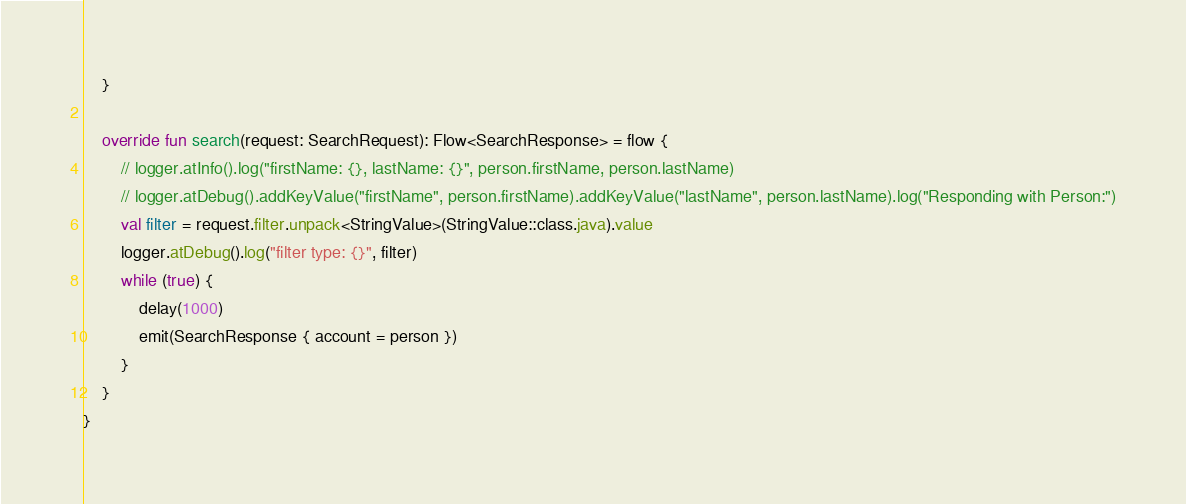<code> <loc_0><loc_0><loc_500><loc_500><_Kotlin_>    }

    override fun search(request: SearchRequest): Flow<SearchResponse> = flow {
        // logger.atInfo().log("firstName: {}, lastName: {}", person.firstName, person.lastName)
        // logger.atDebug().addKeyValue("firstName", person.firstName).addKeyValue("lastName", person.lastName).log("Responding with Person:")
        val filter = request.filter.unpack<StringValue>(StringValue::class.java).value
        logger.atDebug().log("filter type: {}", filter)
        while (true) {
            delay(1000)
            emit(SearchResponse { account = person })
        }
    }
}
</code> 